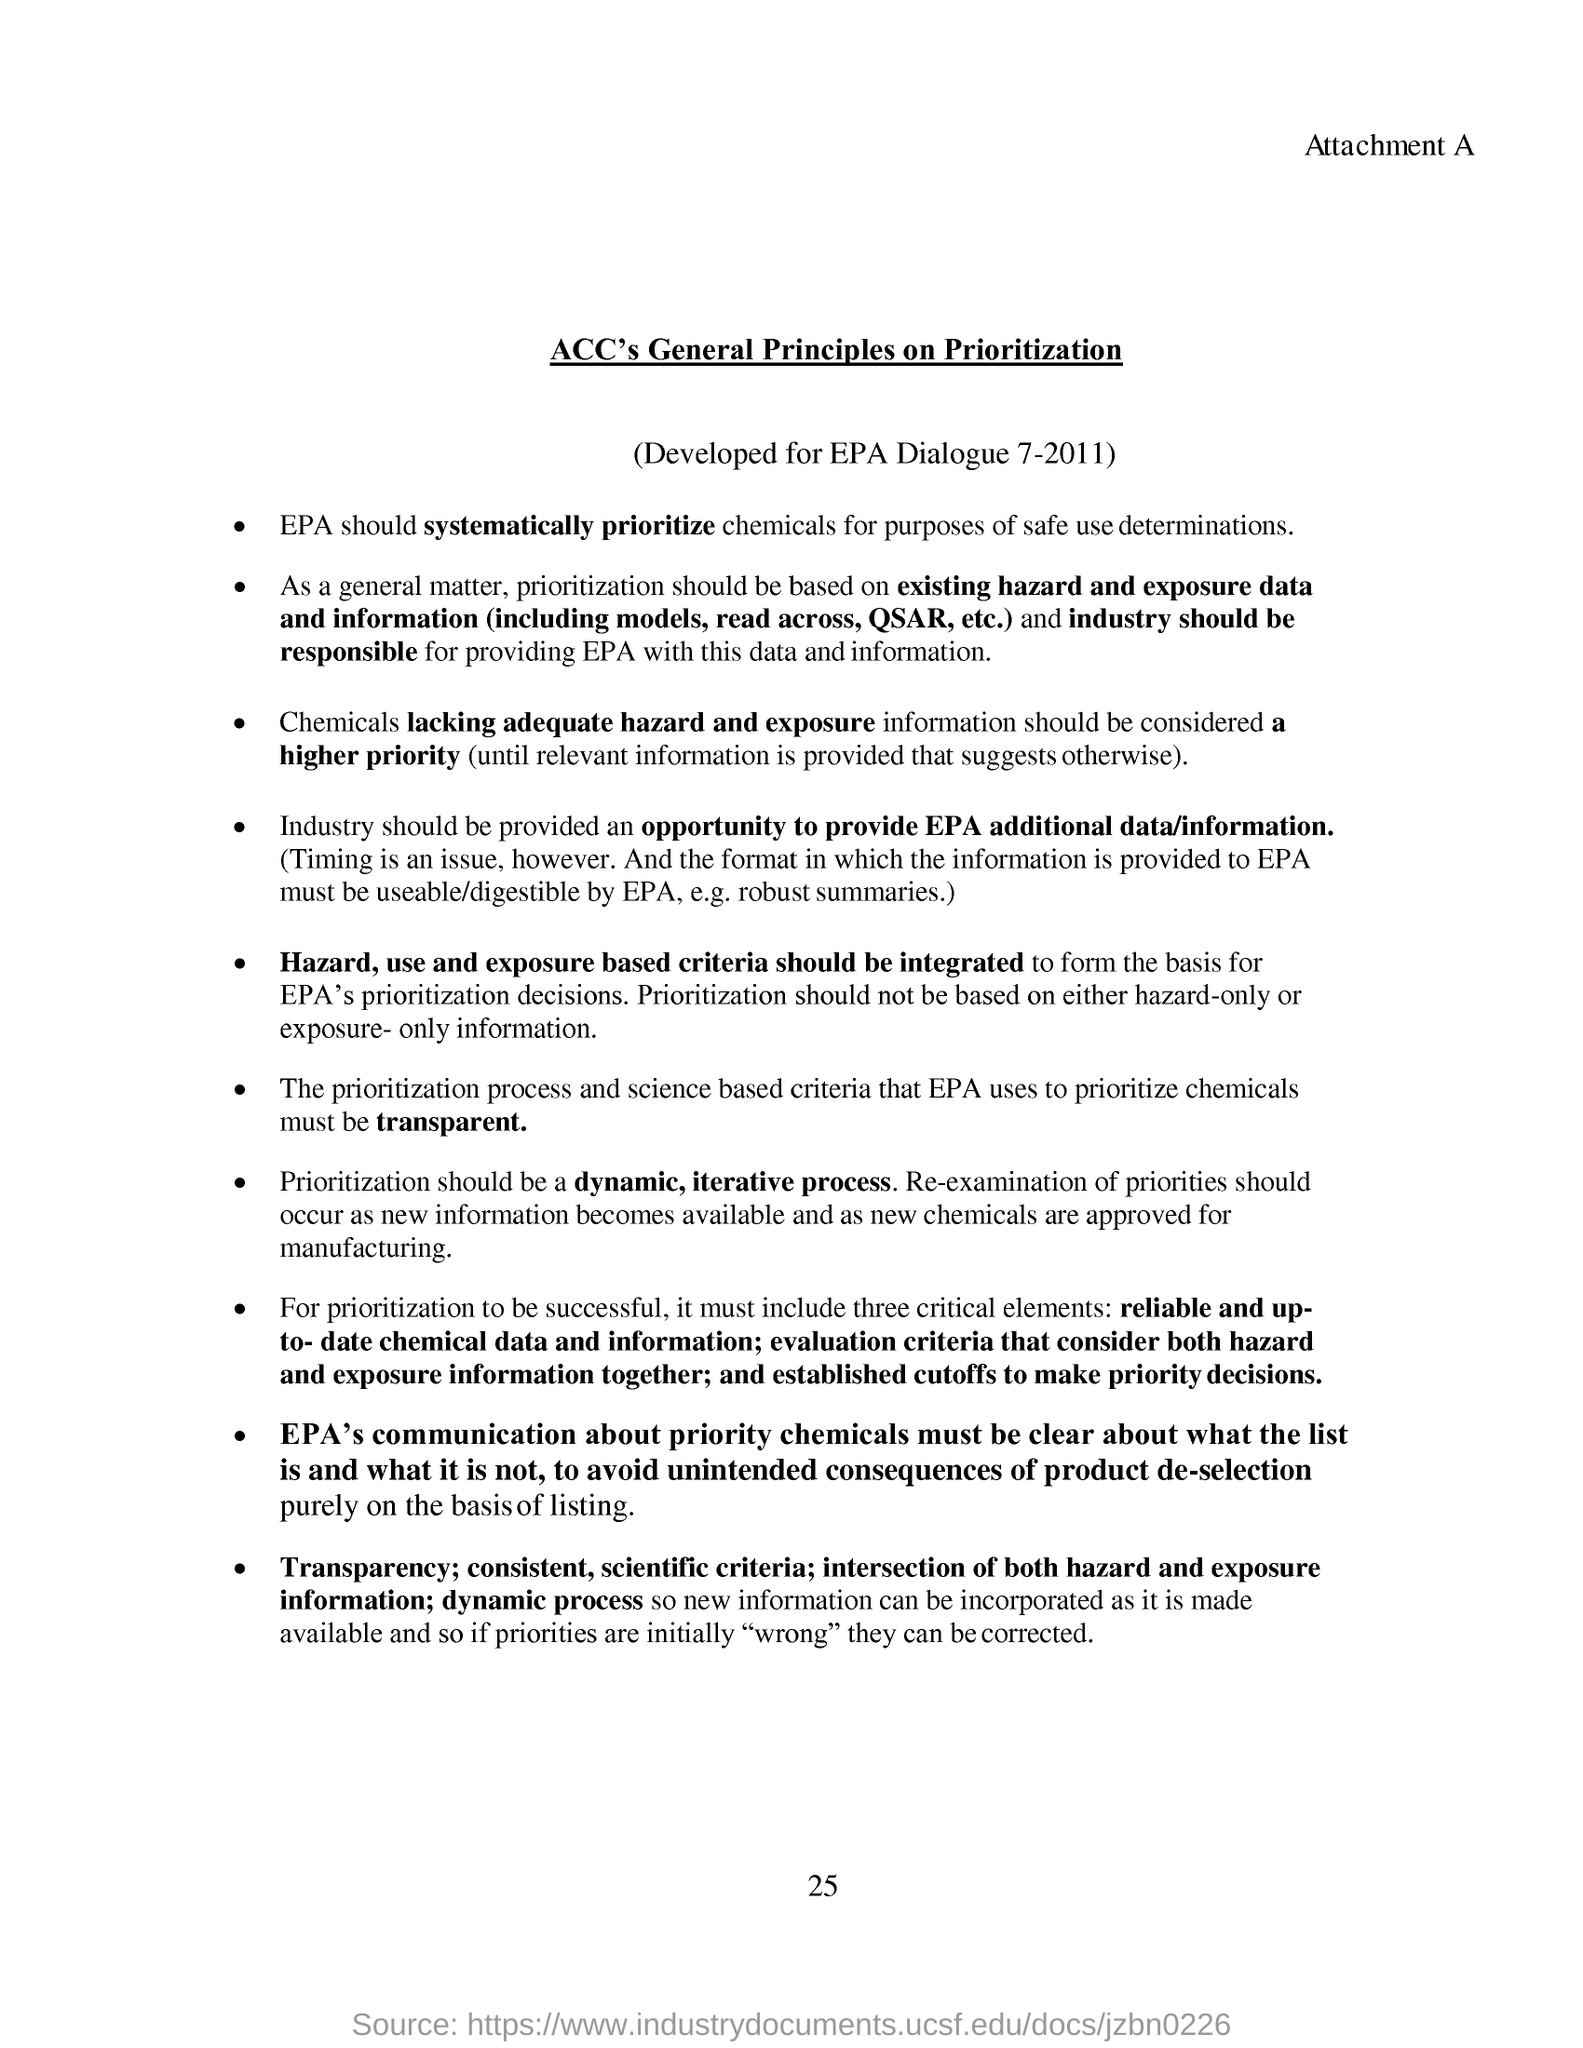Why industry should be provided an opportunity ?
Make the answer very short. To provide epa additional data/information. How should be prioritization process ?
Provide a succinct answer. A dynamic, iterative process. How many critical elements are included for prioritization to be successful ?
Ensure brevity in your answer.  Three. Mention the first point of critical elements under prioritization to be successful
Your answer should be very brief. Reliable and up-to-date chemical data and information. What is the title of this document?
Make the answer very short. ACC's General Principles on Prioritization. 